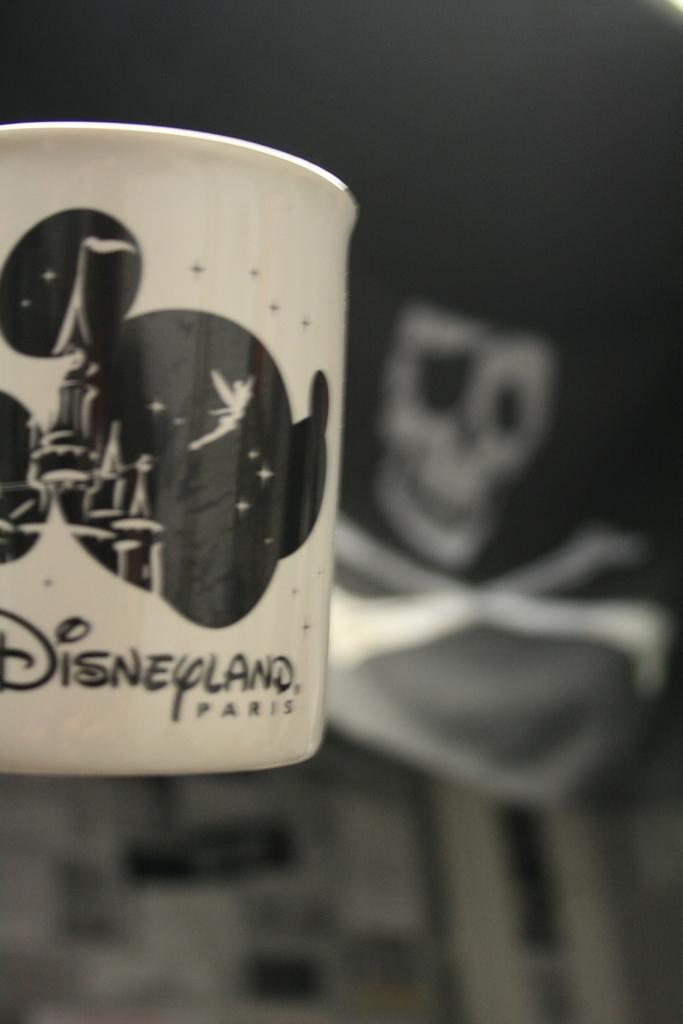Provide a one-sentence caption for the provided image. A Disneyland cup with a skull in the background. 